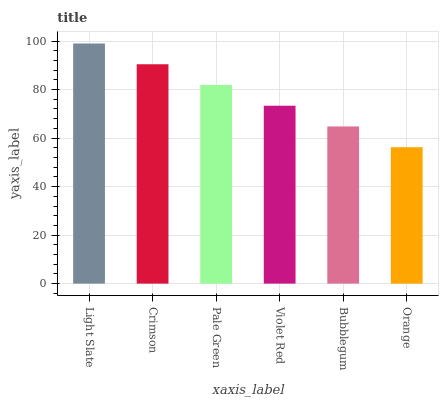Is Orange the minimum?
Answer yes or no. Yes. Is Light Slate the maximum?
Answer yes or no. Yes. Is Crimson the minimum?
Answer yes or no. No. Is Crimson the maximum?
Answer yes or no. No. Is Light Slate greater than Crimson?
Answer yes or no. Yes. Is Crimson less than Light Slate?
Answer yes or no. Yes. Is Crimson greater than Light Slate?
Answer yes or no. No. Is Light Slate less than Crimson?
Answer yes or no. No. Is Pale Green the high median?
Answer yes or no. Yes. Is Violet Red the low median?
Answer yes or no. Yes. Is Violet Red the high median?
Answer yes or no. No. Is Pale Green the low median?
Answer yes or no. No. 